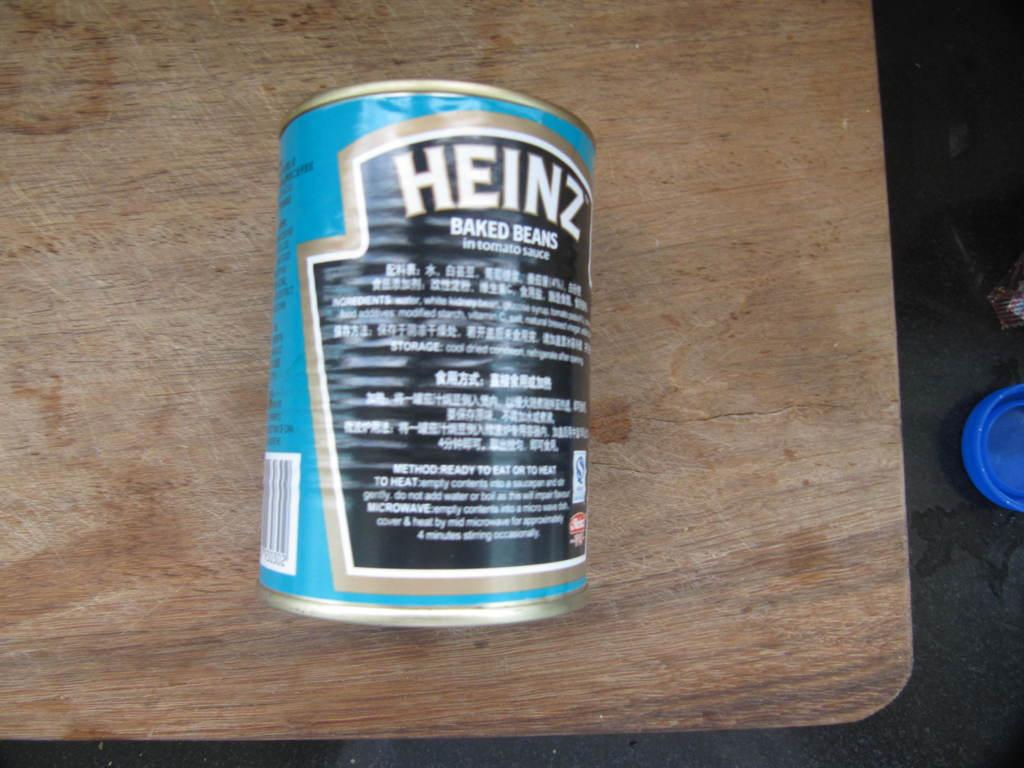Provide a one-sentence caption for the provided image. The back of a blue Heinz branded baked beans. 